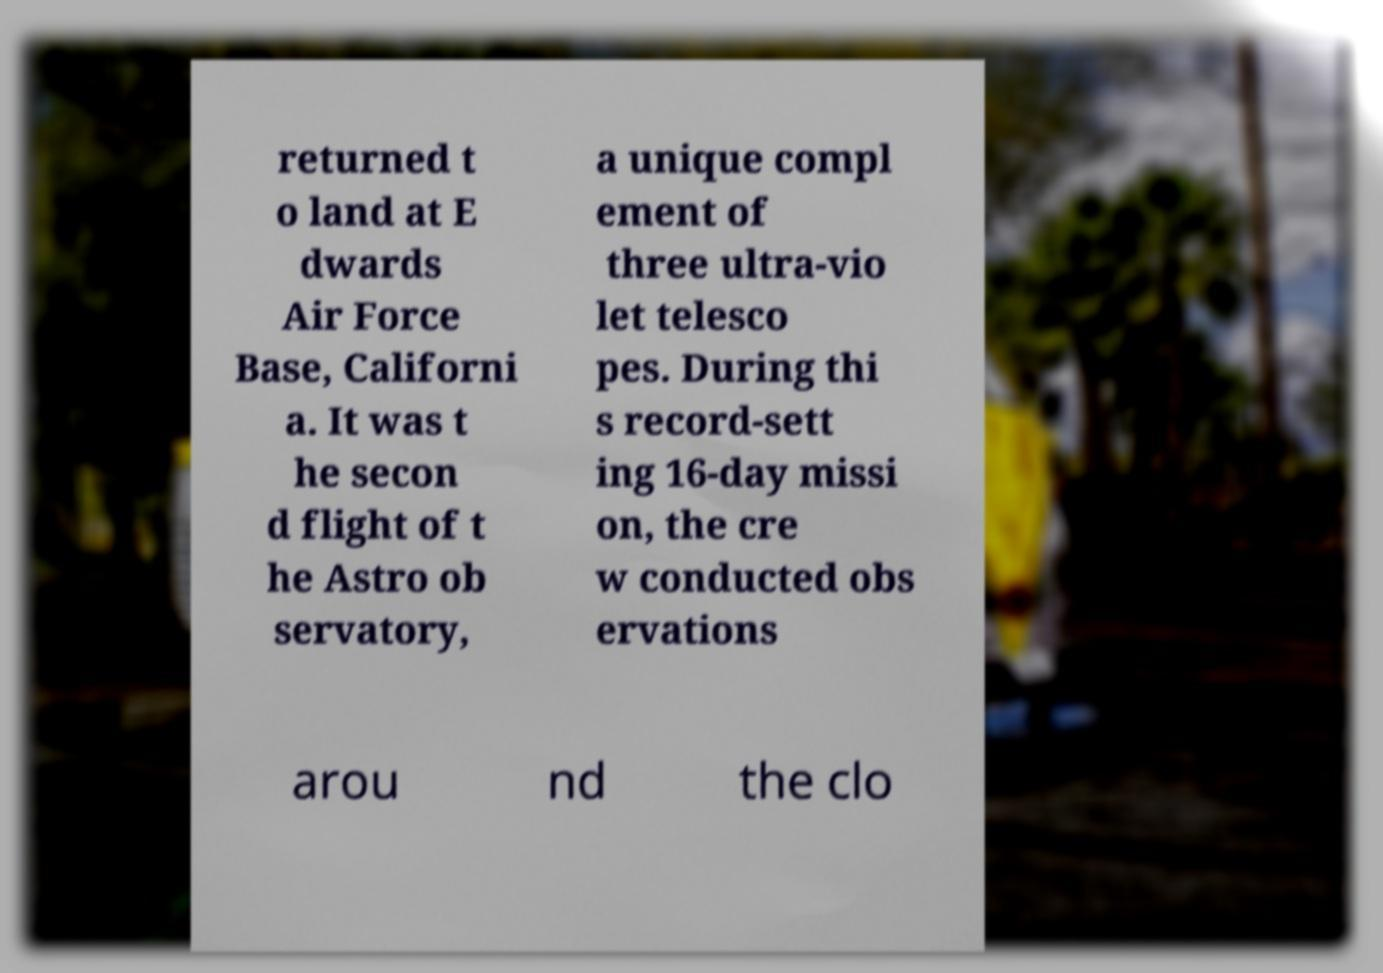There's text embedded in this image that I need extracted. Can you transcribe it verbatim? returned t o land at E dwards Air Force Base, Californi a. It was t he secon d flight of t he Astro ob servatory, a unique compl ement of three ultra-vio let telesco pes. During thi s record-sett ing 16-day missi on, the cre w conducted obs ervations arou nd the clo 